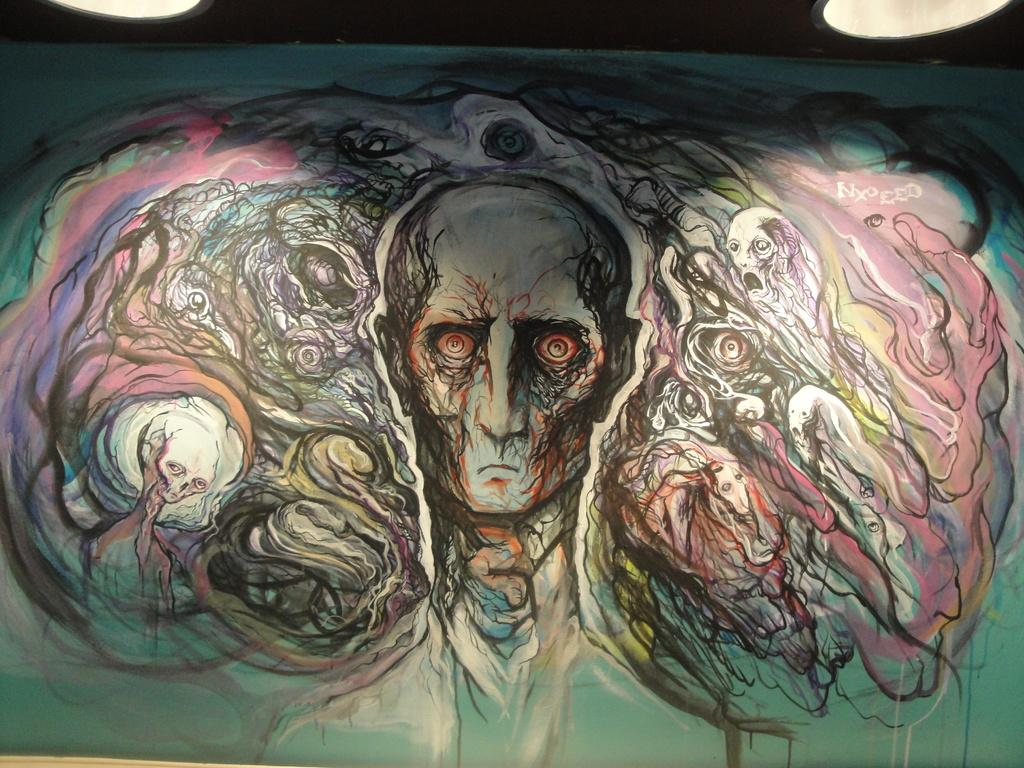What is the main subject of the image? The image contains a painting. What is depicted in the painting? The painting depicts a person. Is the person in the painting taking a bath? There is no indication in the image that the person in the painting is taking a bath. 